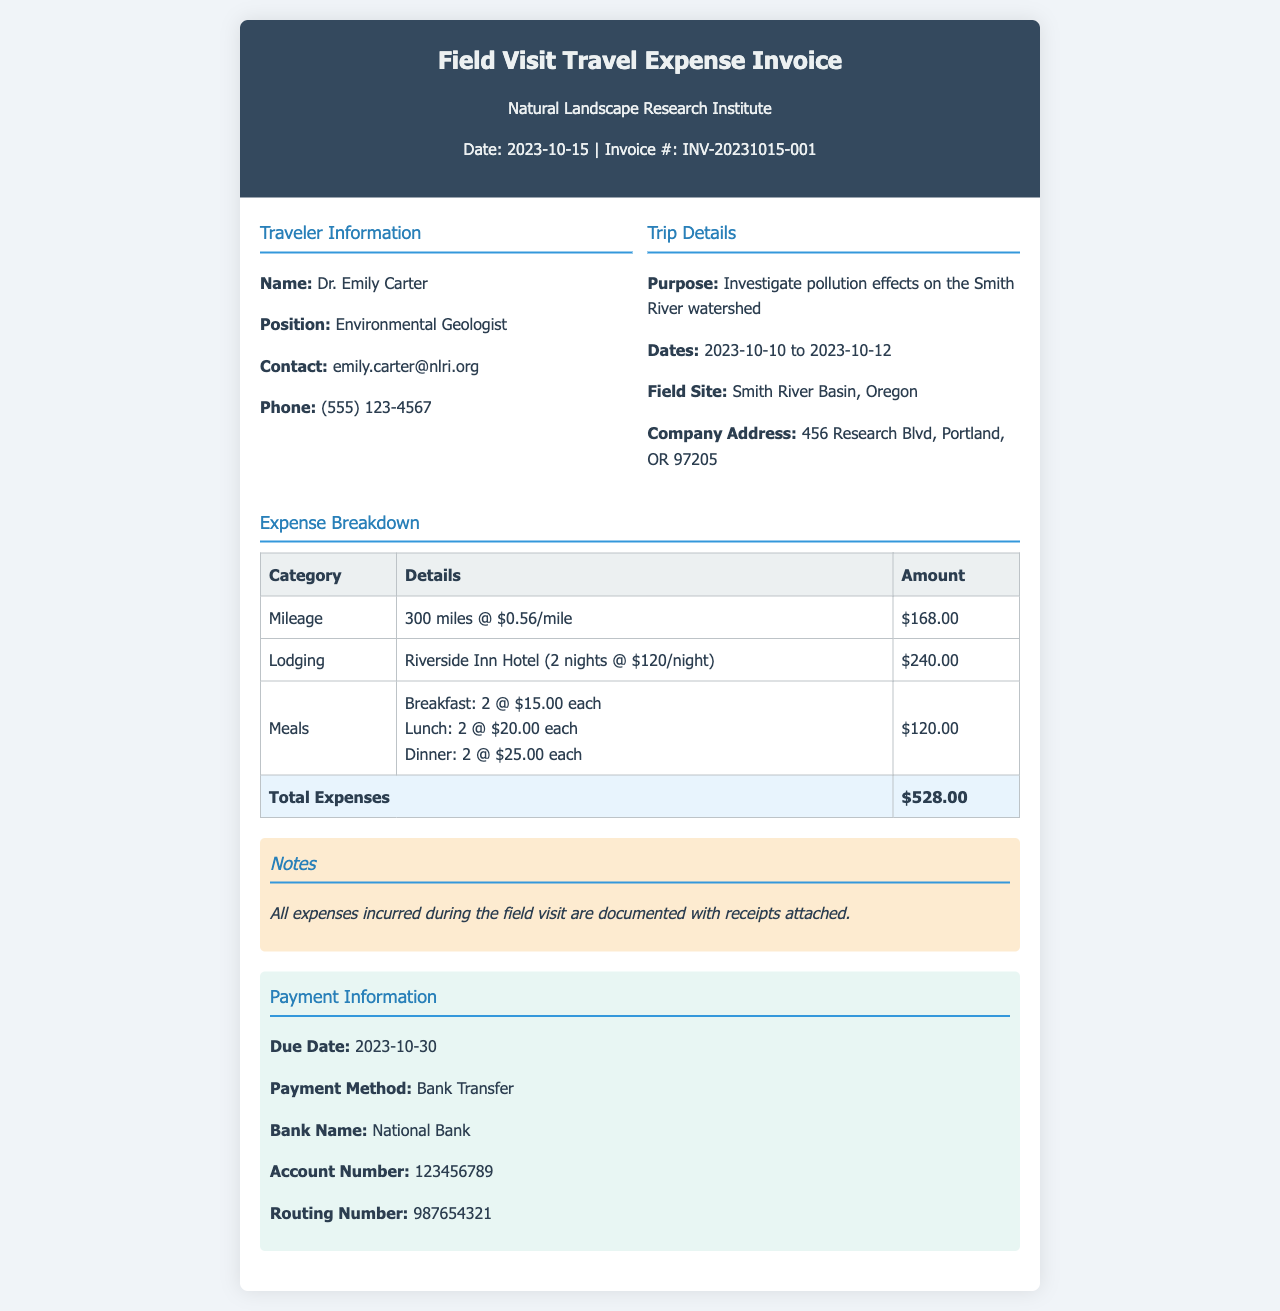What is the invoice date? The invoice date is specified in the document heading, which is 2023-10-15.
Answer: 2023-10-15 Who is the traveler? The traveler's name is listed under Traveler Information, which is Dr. Emily Carter.
Answer: Dr. Emily Carter What is the purpose of the trip? The purpose of the trip is stated in the Trip Details section as investigating pollution effects on the Smith River watershed.
Answer: Investigate pollution effects on the Smith River watershed How much was spent on lodging? The lodging expense is detailed in the Expense Breakdown section and totals $240.00.
Answer: $240.00 What is the total amount of expenses? The total expenses are listed at the end of the Expense Breakdown table, which sums up to $528.00.
Answer: $528.00 What are the meal reimbursements for dinner? The meal reimbursement for dinner is explicitly mentioned as $25.00 each for two dinners, totaling $50.00.
Answer: $50.00 What payment method is specified? The payment method is indicated in the Payment Information section as Bank Transfer.
Answer: Bank Transfer When is the payment due? The due date for payment is provided in the Payment Information section as 2023-10-30.
Answer: 2023-10-30 